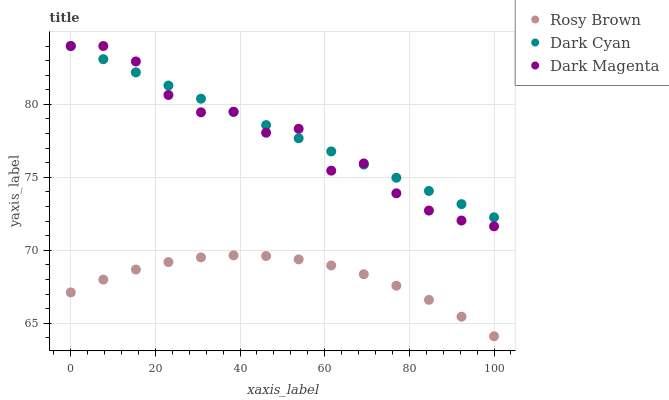Does Rosy Brown have the minimum area under the curve?
Answer yes or no. Yes. Does Dark Cyan have the maximum area under the curve?
Answer yes or no. Yes. Does Dark Magenta have the minimum area under the curve?
Answer yes or no. No. Does Dark Magenta have the maximum area under the curve?
Answer yes or no. No. Is Dark Cyan the smoothest?
Answer yes or no. Yes. Is Dark Magenta the roughest?
Answer yes or no. Yes. Is Rosy Brown the smoothest?
Answer yes or no. No. Is Rosy Brown the roughest?
Answer yes or no. No. Does Rosy Brown have the lowest value?
Answer yes or no. Yes. Does Dark Magenta have the lowest value?
Answer yes or no. No. Does Dark Magenta have the highest value?
Answer yes or no. Yes. Does Rosy Brown have the highest value?
Answer yes or no. No. Is Rosy Brown less than Dark Magenta?
Answer yes or no. Yes. Is Dark Magenta greater than Rosy Brown?
Answer yes or no. Yes. Does Dark Magenta intersect Dark Cyan?
Answer yes or no. Yes. Is Dark Magenta less than Dark Cyan?
Answer yes or no. No. Is Dark Magenta greater than Dark Cyan?
Answer yes or no. No. Does Rosy Brown intersect Dark Magenta?
Answer yes or no. No. 